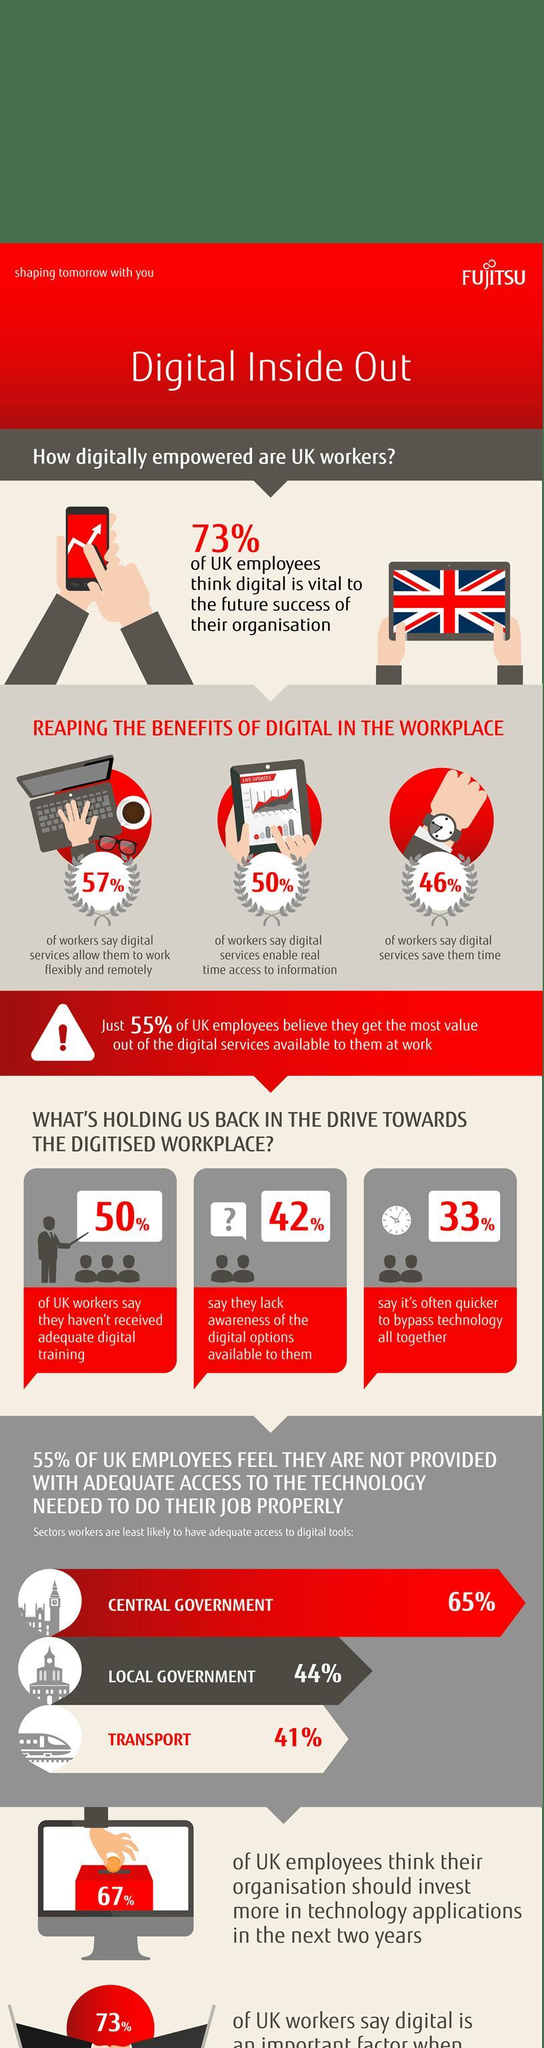What percent of UK workers say it is not often quicker to bypass technology all together?
Answer the question with a short phrase. 67% 